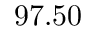<formula> <loc_0><loc_0><loc_500><loc_500>9 7 . 5 0</formula> 